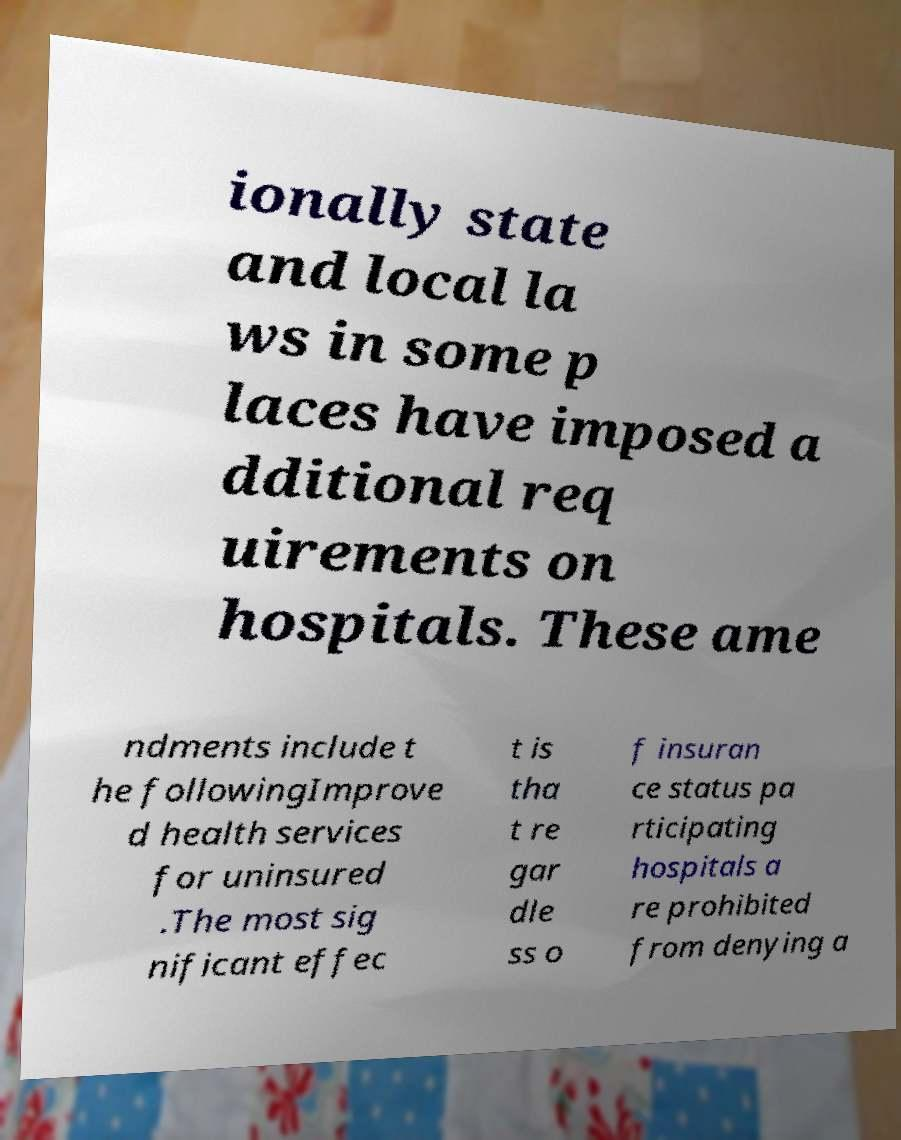Could you extract and type out the text from this image? ionally state and local la ws in some p laces have imposed a dditional req uirements on hospitals. These ame ndments include t he followingImprove d health services for uninsured .The most sig nificant effec t is tha t re gar dle ss o f insuran ce status pa rticipating hospitals a re prohibited from denying a 